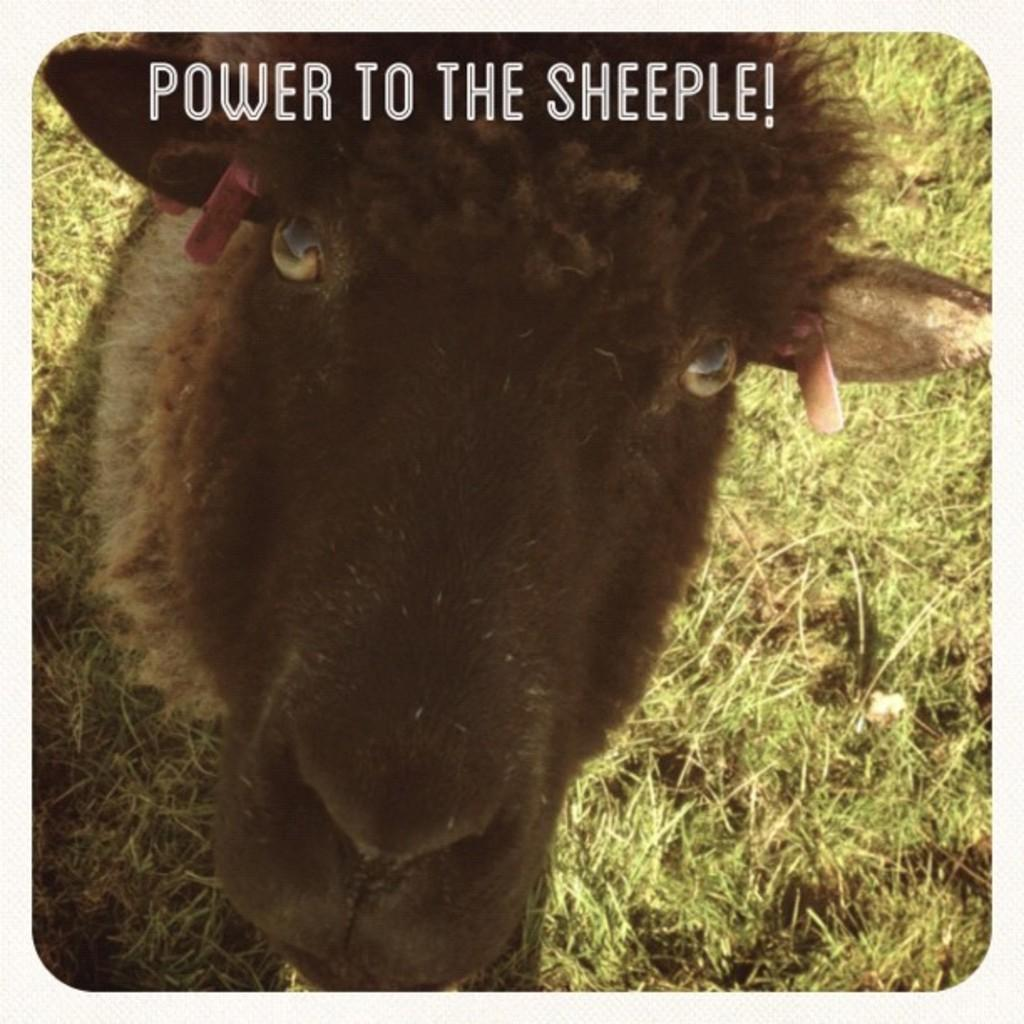What type of animal can be seen in the image? There is a sheep in the image. What is on the ground in the image? There are grasses on the ground in the image. What can be seen at the top of the image? There is text or writing visible at the top of the image. What type of medical advice is the sheep giving in the image? There is no indication in the image that the sheep is giving medical advice or functioning as a doctor. 